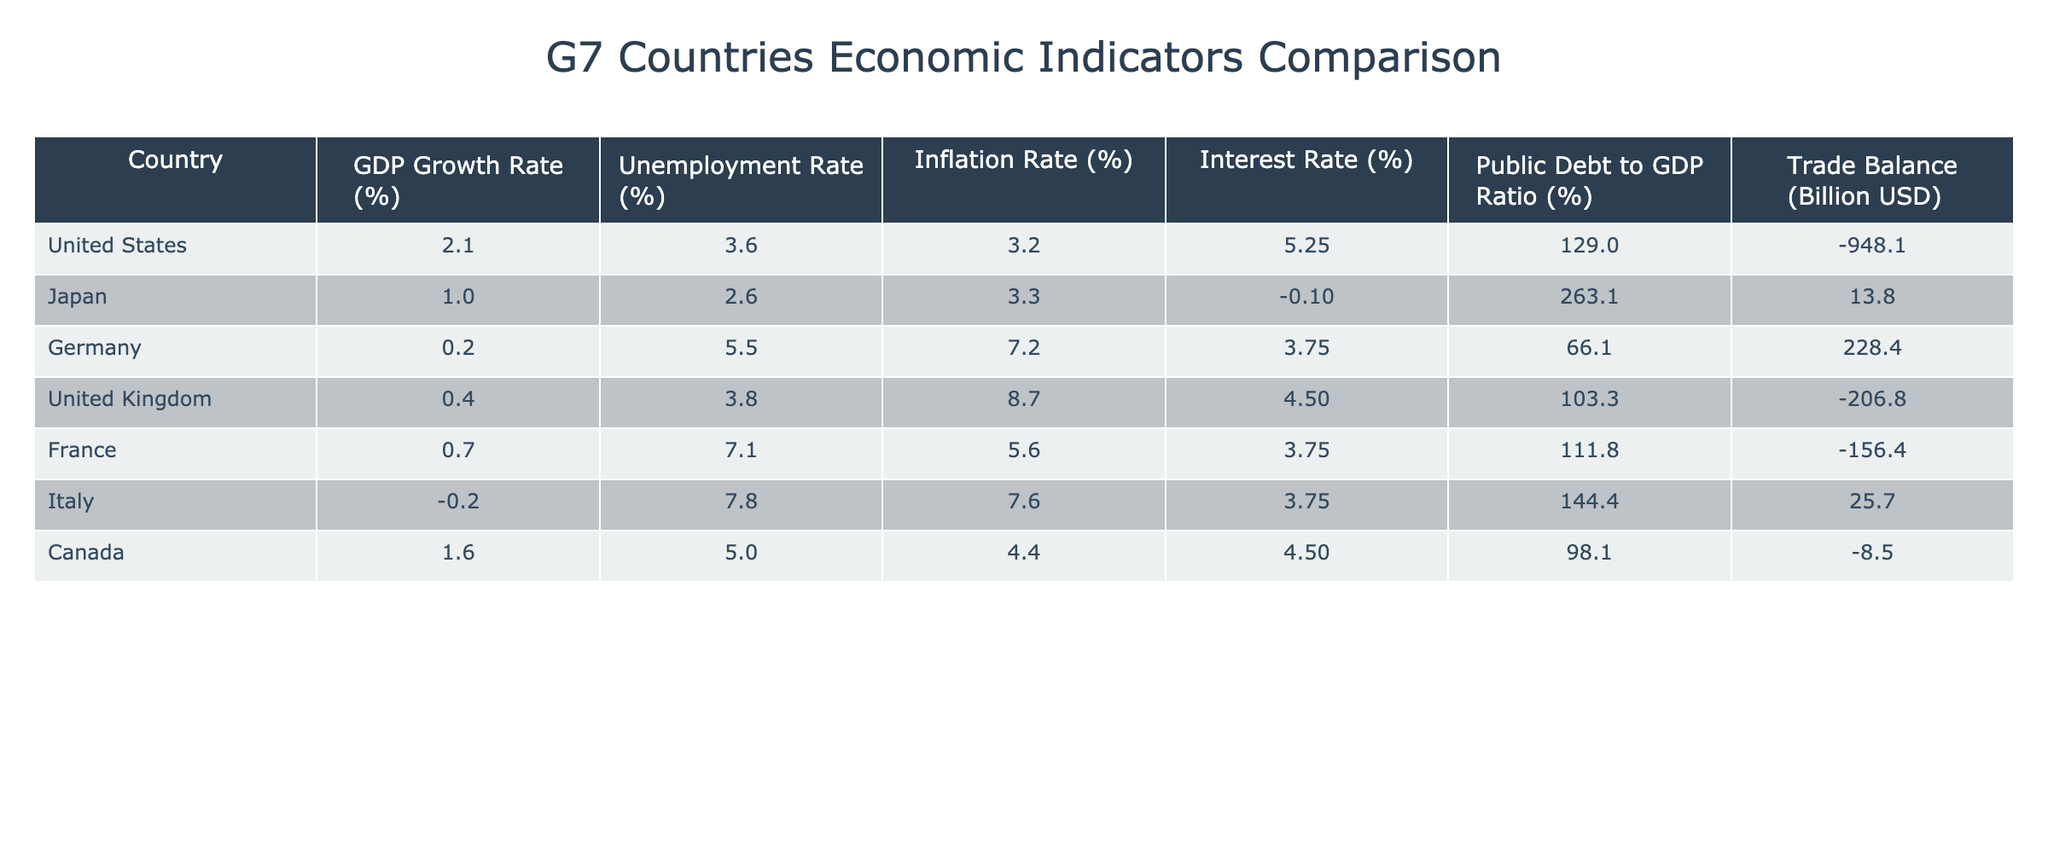What is the GDP growth rate of Germany? The table lists the GDP growth rate for Germany, which is specified directly as 0.2%.
Answer: 0.2% Which country has the highest unemployment rate? By examining the unemployment rates listed in the table, Italy has the highest rate at 7.8%.
Answer: Italy What is the average inflation rate across all G7 countries? To find the average inflation rate, sum the values: 3.2 + 3.3 + 7.2 + 8.7 + 5.6 + 7.6 + 4.4 = 40.0. Then divide by the number of countries (7): 40.0 / 7 = approximately 5.71%.
Answer: 5.71% Is the public debt to GDP ratio for Canada higher than that of France? The ratio for Canada is 98.1% and for France is 111.8%. Since 98.1% is less than 111.8%, the statement is false.
Answer: No What is the trade balance difference between the United States and Germany? The trade balance for the United States is -948.1 billion USD and for Germany is 228.4 billion USD. The difference is calculated as -948.1 - 228.4 = -1176.5 billion USD.
Answer: -1176.5 billion USD Is the interest rate for Japan negative? The interest rate for Japan is listed as -0.1%, which is indeed negative. Therefore, the answer is true.
Answer: Yes Which country has the lowest GDP growth rate? Among the listed GDP growth rates, Italy has the lowest at -0.2%, making it the country with the lowest growth rate in the table.
Answer: Italy What is the total public debt to GDP ratio of G7 countries as a group? The total ratio would require summing each country's value: 129.0 + 263.1 + 66.1 + 103.3 + 111.8 + 144.4 + 98.1 =  815.8%. There are 7 countries, so the average ratio is  815.8 / 7 ≈ 116.54%.
Answer: 116.54% 